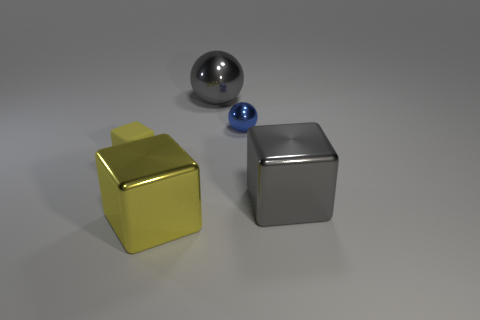There is another ball that is the same material as the tiny blue ball; what is its color?
Your answer should be compact. Gray. What number of other large spheres are the same material as the gray ball?
Your response must be concise. 0. There is a big gray metal cube; how many big blocks are left of it?
Keep it short and to the point. 1. Does the thing that is to the left of the large yellow thing have the same material as the gray thing that is in front of the blue metal sphere?
Provide a succinct answer. No. Are there more big gray shiny balls that are in front of the large yellow object than yellow rubber objects behind the small yellow matte block?
Provide a short and direct response. No. What is the material of the large object that is the same color as the big sphere?
Your answer should be compact. Metal. Is there any other thing that has the same shape as the small yellow rubber thing?
Keep it short and to the point. Yes. The big thing that is on the left side of the gray block and in front of the small sphere is made of what material?
Ensure brevity in your answer.  Metal. Is the material of the big gray ball the same as the object on the right side of the small blue metallic sphere?
Provide a short and direct response. Yes. Is there any other thing that has the same size as the yellow shiny object?
Your answer should be very brief. Yes. 